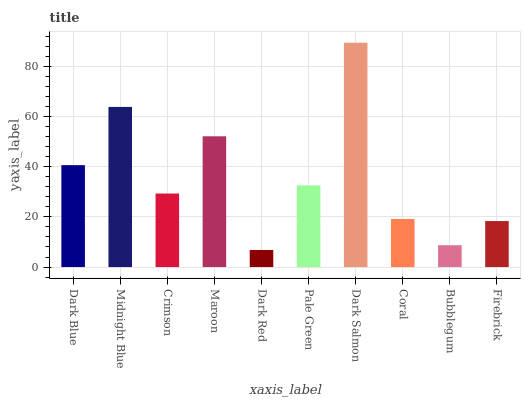Is Dark Red the minimum?
Answer yes or no. Yes. Is Dark Salmon the maximum?
Answer yes or no. Yes. Is Midnight Blue the minimum?
Answer yes or no. No. Is Midnight Blue the maximum?
Answer yes or no. No. Is Midnight Blue greater than Dark Blue?
Answer yes or no. Yes. Is Dark Blue less than Midnight Blue?
Answer yes or no. Yes. Is Dark Blue greater than Midnight Blue?
Answer yes or no. No. Is Midnight Blue less than Dark Blue?
Answer yes or no. No. Is Pale Green the high median?
Answer yes or no. Yes. Is Crimson the low median?
Answer yes or no. Yes. Is Midnight Blue the high median?
Answer yes or no. No. Is Bubblegum the low median?
Answer yes or no. No. 